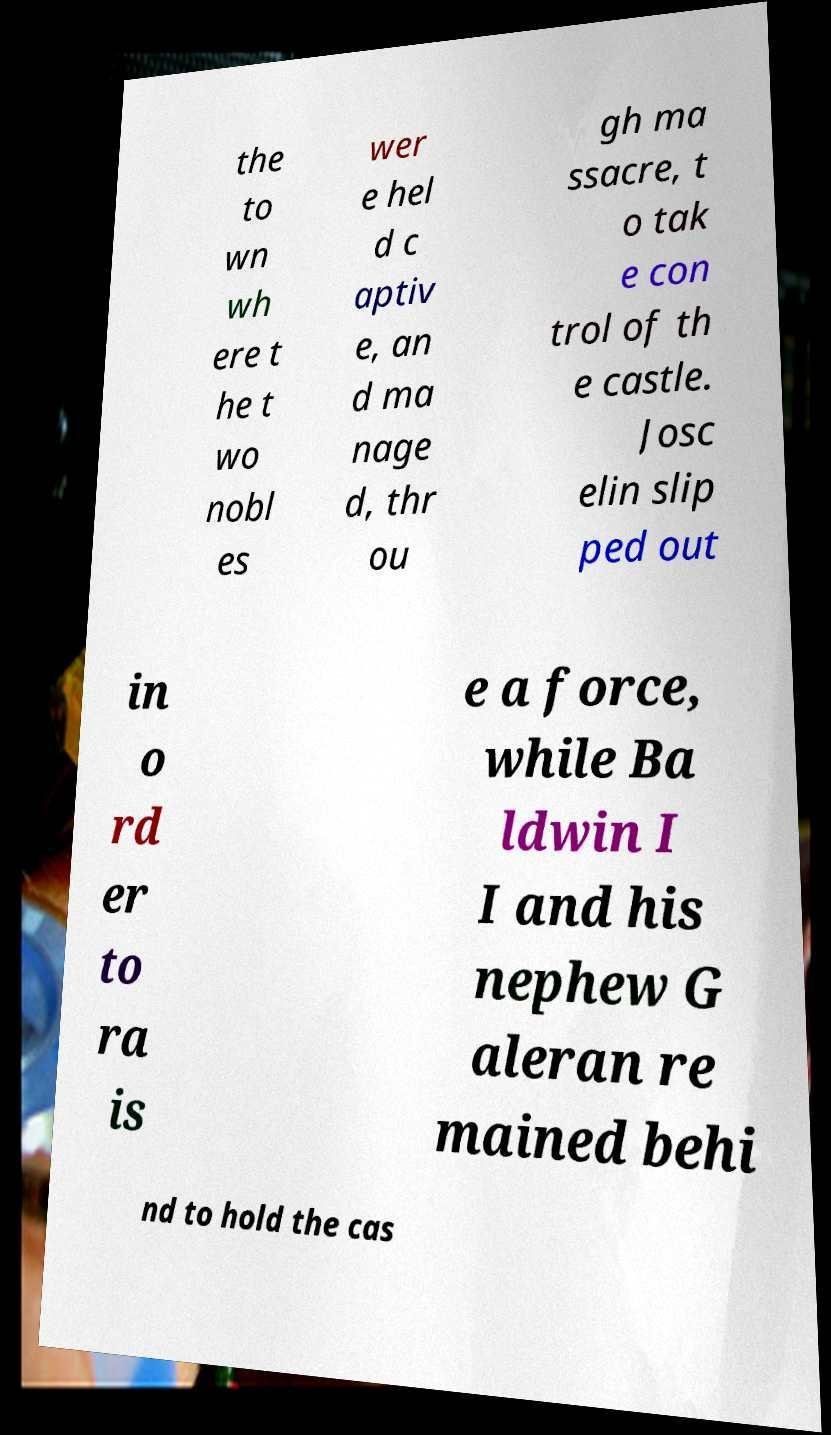Can you accurately transcribe the text from the provided image for me? the to wn wh ere t he t wo nobl es wer e hel d c aptiv e, an d ma nage d, thr ou gh ma ssacre, t o tak e con trol of th e castle. Josc elin slip ped out in o rd er to ra is e a force, while Ba ldwin I I and his nephew G aleran re mained behi nd to hold the cas 